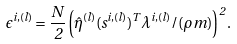Convert formula to latex. <formula><loc_0><loc_0><loc_500><loc_500>\epsilon ^ { i , ( l ) } = \frac { N } { 2 } \left ( \hat { \eta } ^ { ( l ) } ( s ^ { i , ( l ) } ) ^ { T } \lambda ^ { i , ( l ) } / ( \rho m ) \right ) ^ { 2 } .</formula> 